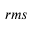Convert formula to latex. <formula><loc_0><loc_0><loc_500><loc_500>_ { r m s }</formula> 